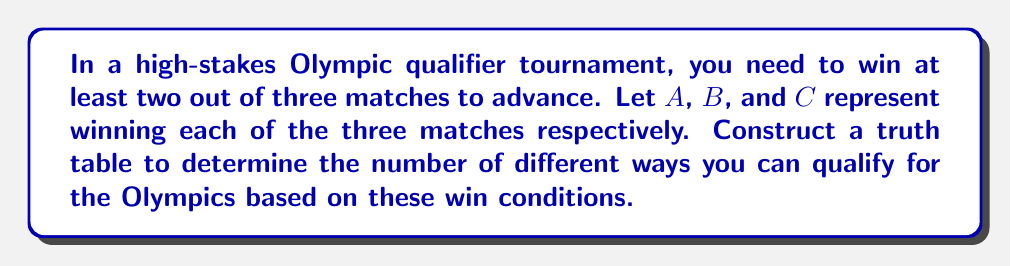Teach me how to tackle this problem. Let's approach this step-by-step:

1) First, we need to create a truth table with three variables: $A$, $B$, and $C$. This will give us $2^3 = 8$ possible combinations.

2) We'll add a column for the qualification condition, which we can represent as $Q$. We qualify if we win at least two matches.

3) Here's the truth table:

   $$
   \begin{array}{|c|c|c|c|}
   \hline
   A & B & C & Q \\
   \hline
   0 & 0 & 0 & 0 \\
   0 & 0 & 1 & 0 \\
   0 & 1 & 0 & 0 \\
   0 & 1 & 1 & 1 \\
   1 & 0 & 0 & 0 \\
   1 & 0 & 1 & 1 \\
   1 & 1 & 0 & 1 \\
   1 & 1 & 1 & 1 \\
   \hline
   \end{array}
   $$

4) The Boolean expression for qualifying can be written as:
   
   $Q = AB + AC + BC$

5) To count the number of ways to qualify, we count the number of rows where $Q = 1$.

6) From the truth table, we can see that there are 4 rows where $Q = 1$.

Therefore, there are 4 different ways to qualify for the Olympics based on these win conditions.
Answer: 4 